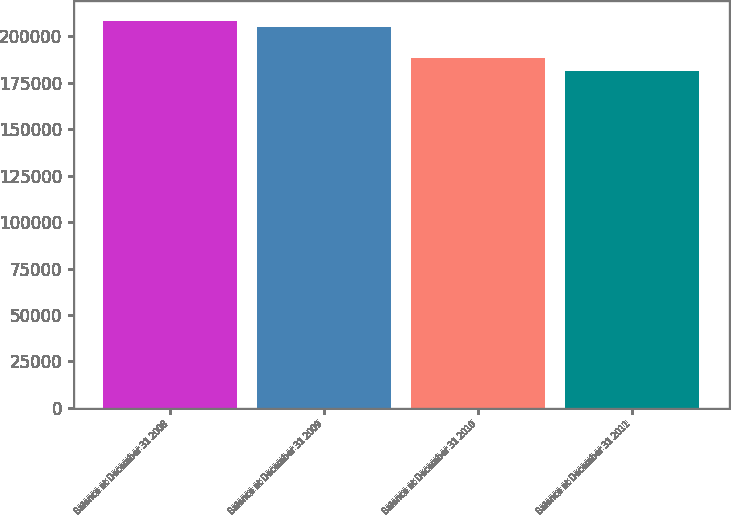Convert chart. <chart><loc_0><loc_0><loc_500><loc_500><bar_chart><fcel>Balance at December 31 2008<fcel>Balance at December 31 2009<fcel>Balance at December 31 2010<fcel>Balance at December 31 2011<nl><fcel>208391<fcel>205005<fcel>188154<fcel>181165<nl></chart> 